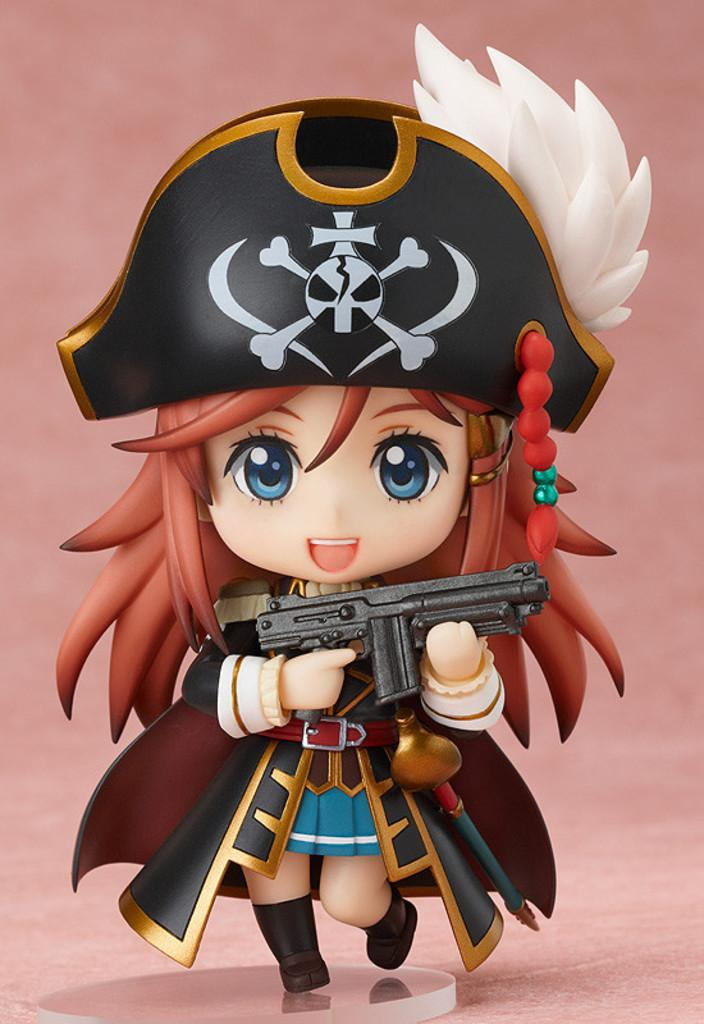What type of image is this? The image is animated. What can be seen in the animated image? There is a cartoon toy in the image. What is the cartoon toy holding? The cartoon toy is holding a gun. What color is the background of the image? The background color is pink. How many balls are visible in the image? There are no balls present in the image. Can you see any sails in the image? There are no sails present in the image. 